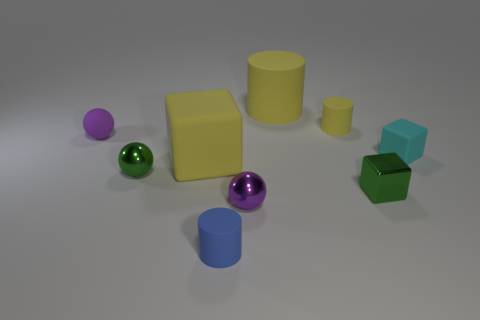Subtract all metal balls. How many balls are left? 1 Subtract 1 cylinders. How many cylinders are left? 2 Subtract all yellow cylinders. How many cylinders are left? 1 Add 4 large matte cylinders. How many large matte cylinders exist? 5 Subtract 1 green blocks. How many objects are left? 8 Subtract all yellow cylinders. Subtract all red balls. How many cylinders are left? 1 Subtract all blue balls. How many yellow blocks are left? 1 Subtract all purple matte spheres. Subtract all tiny yellow matte cylinders. How many objects are left? 7 Add 4 small green balls. How many small green balls are left? 5 